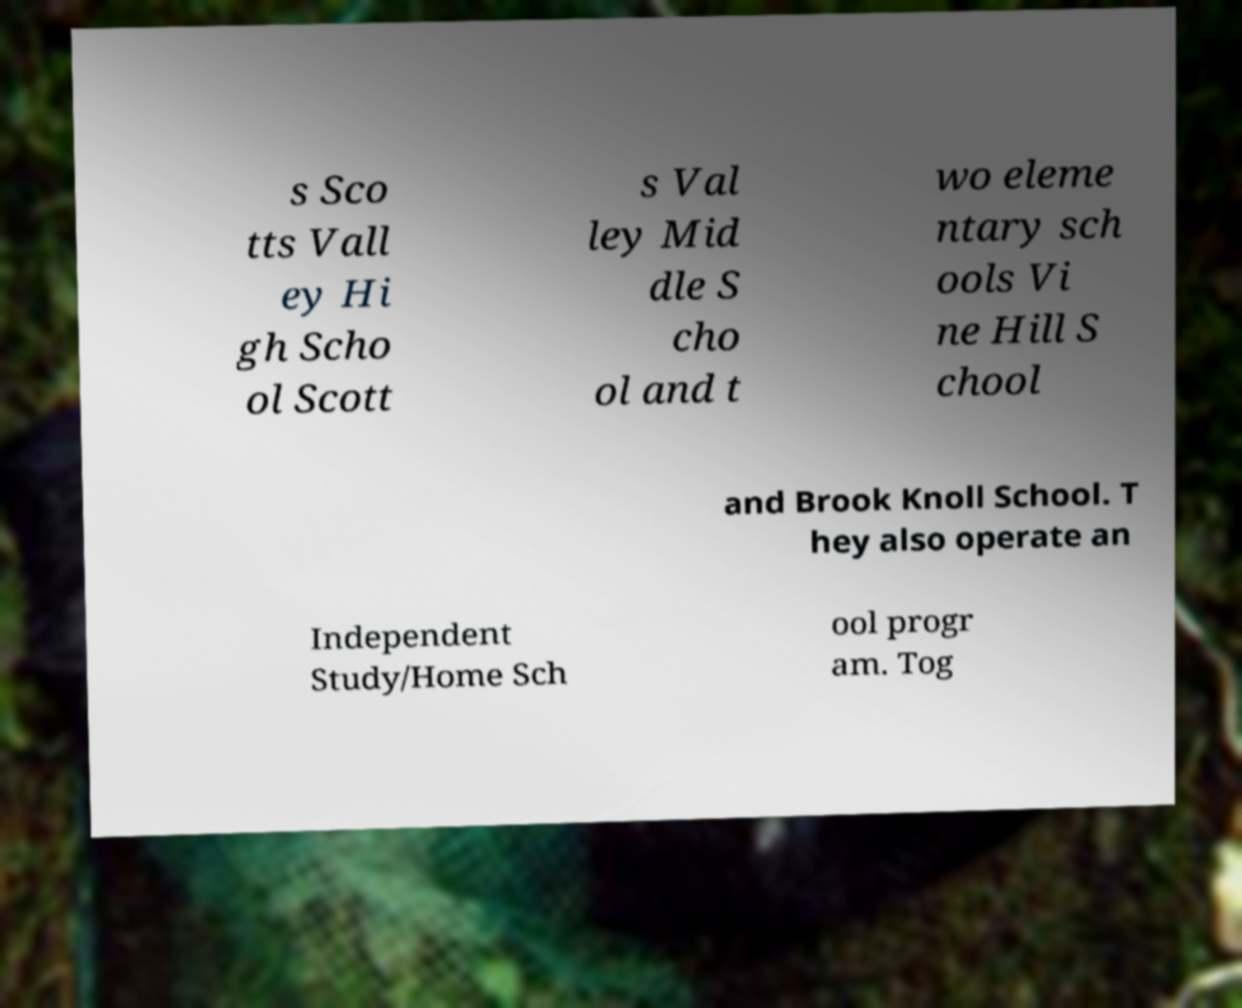Can you accurately transcribe the text from the provided image for me? s Sco tts Vall ey Hi gh Scho ol Scott s Val ley Mid dle S cho ol and t wo eleme ntary sch ools Vi ne Hill S chool and Brook Knoll School. T hey also operate an Independent Study/Home Sch ool progr am. Tog 